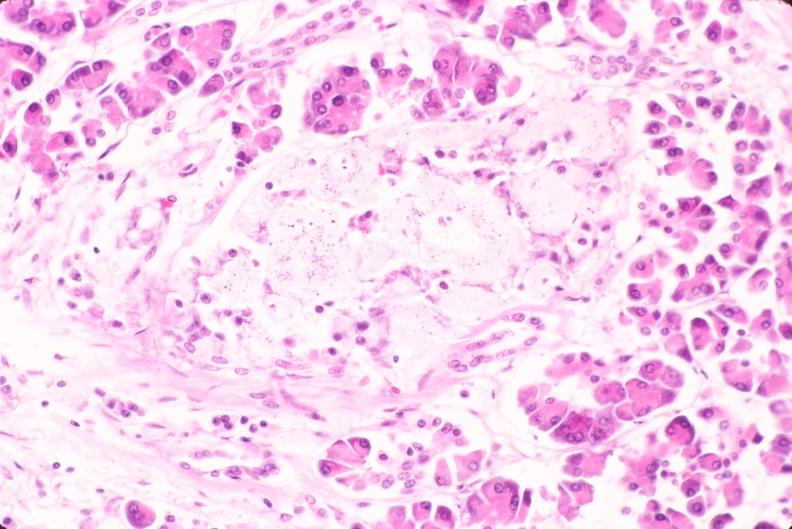what is present?
Answer the question using a single word or phrase. Endocrine 